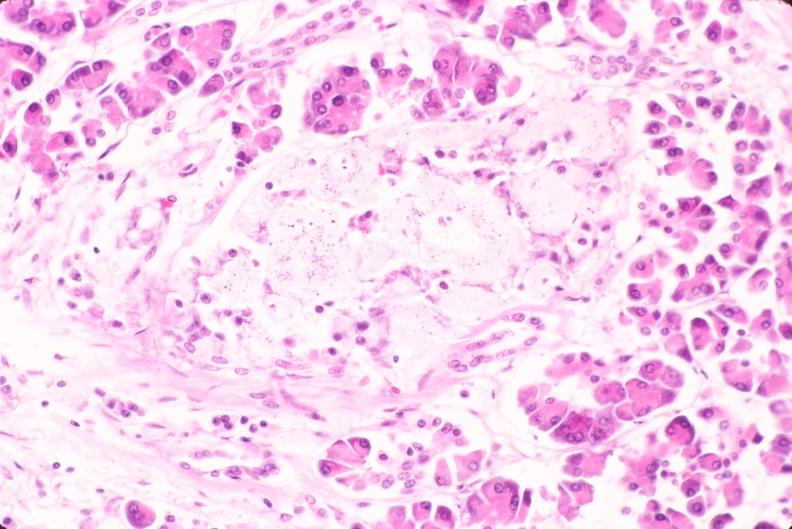what is present?
Answer the question using a single word or phrase. Endocrine 